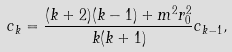Convert formula to latex. <formula><loc_0><loc_0><loc_500><loc_500>c _ { k } = \frac { ( k + 2 ) ( k - 1 ) + m ^ { 2 } r _ { 0 } ^ { 2 } } { k ( k + 1 ) } c _ { k - 1 } ,</formula> 